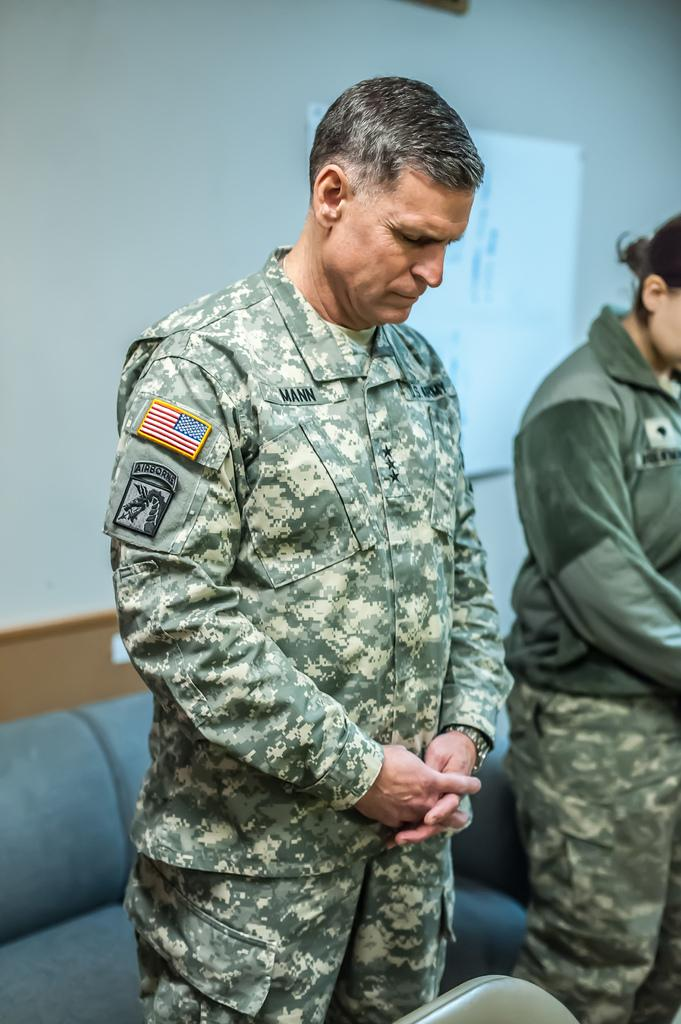How many people are in the image? There are two persons in the image. What are the persons wearing? The persons are wearing green color uniforms. What can be seen in the background of the image? There is a couch and a wall in the background of the image. What colors are the couch and the wall? The couch is gray in color, and the wall is white in color. What type of organization do the persons belong to, as indicated by their uniforms? The image does not provide any information about the organization the persons belong to, as it only shows their green color uniforms. Can you describe the sweater worn by the person on the left? There is no sweater visible on the person on the left, as they are wearing a green color uniform. 